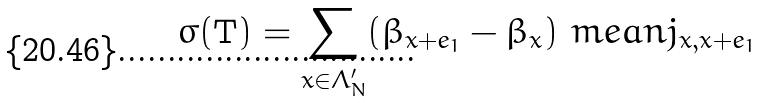Convert formula to latex. <formula><loc_0><loc_0><loc_500><loc_500>\sigma ( \mathbf T ) = \sum _ { x \in \Lambda ^ { \prime } _ { N } } ( \beta _ { x + e _ { 1 } } - \beta _ { x } ) \ m e a n { j _ { x , x + e _ { 1 } } }</formula> 